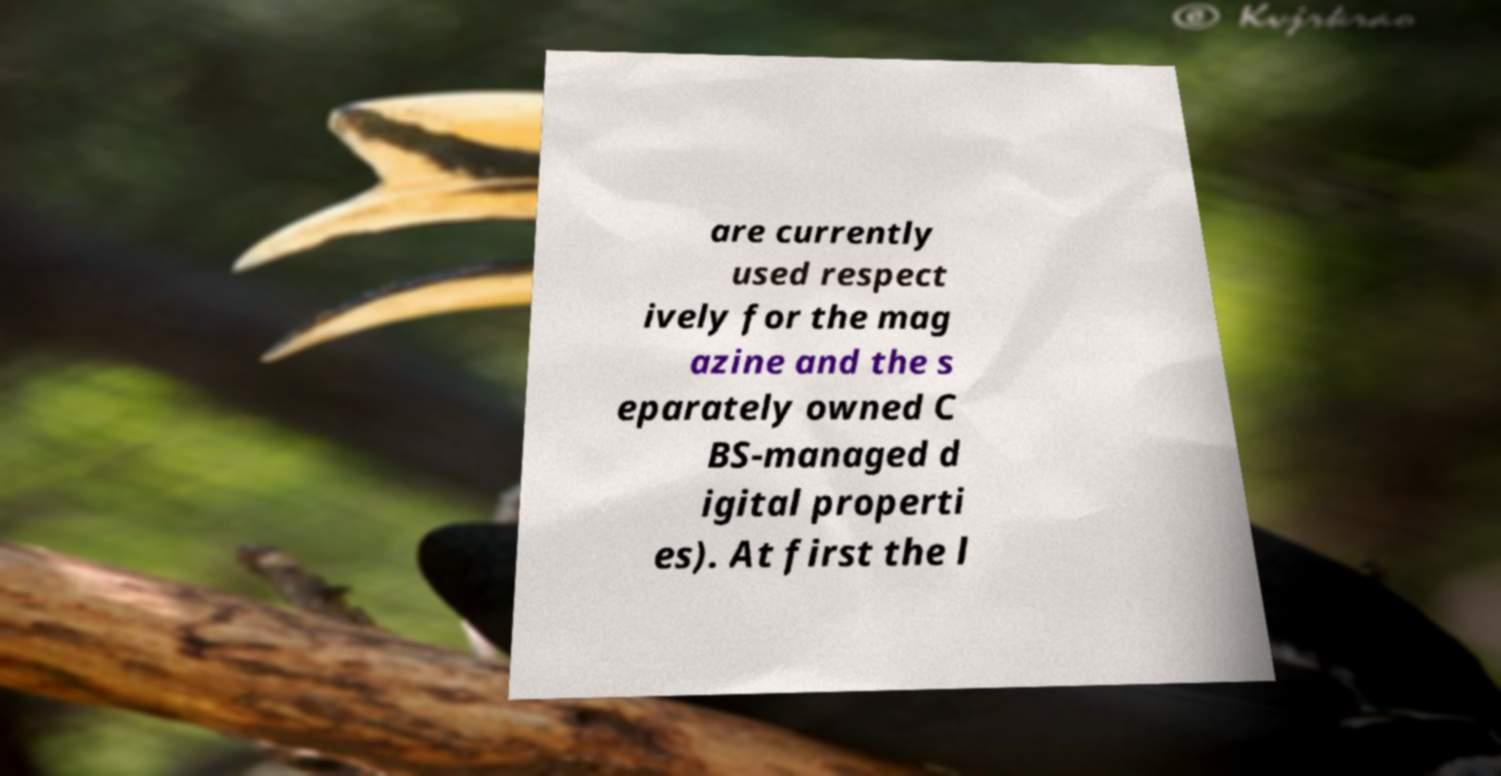There's text embedded in this image that I need extracted. Can you transcribe it verbatim? are currently used respect ively for the mag azine and the s eparately owned C BS-managed d igital properti es). At first the l 